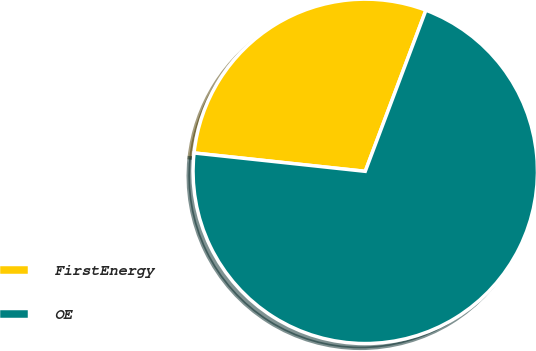Convert chart. <chart><loc_0><loc_0><loc_500><loc_500><pie_chart><fcel>FirstEnergy<fcel>OE<nl><fcel>29.03%<fcel>70.97%<nl></chart> 